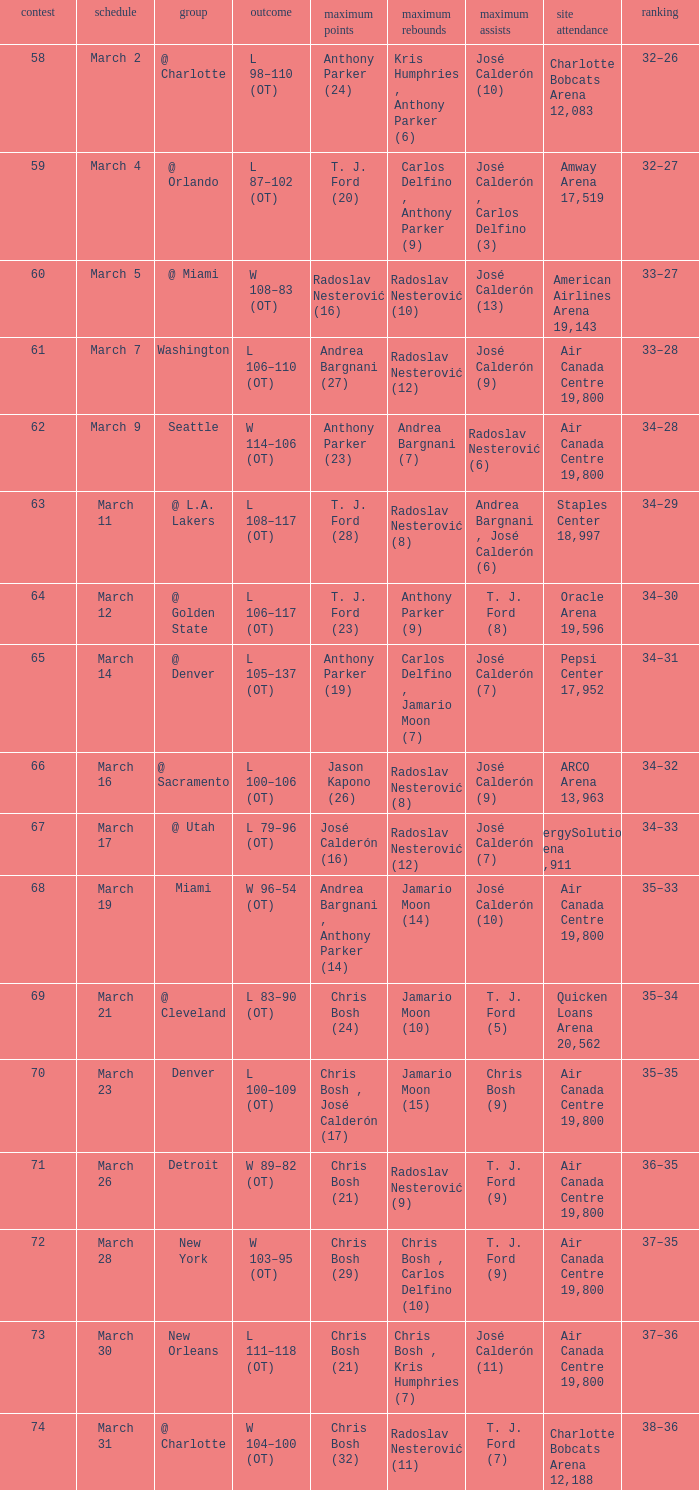Write the full table. {'header': ['contest', 'schedule', 'group', 'outcome', 'maximum points', 'maximum rebounds', 'maximum assists', 'site attendance', 'ranking'], 'rows': [['58', 'March 2', '@ Charlotte', 'L 98–110 (OT)', 'Anthony Parker (24)', 'Kris Humphries , Anthony Parker (6)', 'José Calderón (10)', 'Charlotte Bobcats Arena 12,083', '32–26'], ['59', 'March 4', '@ Orlando', 'L 87–102 (OT)', 'T. J. Ford (20)', 'Carlos Delfino , Anthony Parker (9)', 'José Calderón , Carlos Delfino (3)', 'Amway Arena 17,519', '32–27'], ['60', 'March 5', '@ Miami', 'W 108–83 (OT)', 'Radoslav Nesterović (16)', 'Radoslav Nesterović (10)', 'José Calderón (13)', 'American Airlines Arena 19,143', '33–27'], ['61', 'March 7', 'Washington', 'L 106–110 (OT)', 'Andrea Bargnani (27)', 'Radoslav Nesterović (12)', 'José Calderón (9)', 'Air Canada Centre 19,800', '33–28'], ['62', 'March 9', 'Seattle', 'W 114–106 (OT)', 'Anthony Parker (23)', 'Andrea Bargnani (7)', 'Radoslav Nesterović (6)', 'Air Canada Centre 19,800', '34–28'], ['63', 'March 11', '@ L.A. Lakers', 'L 108–117 (OT)', 'T. J. Ford (28)', 'Radoslav Nesterović (8)', 'Andrea Bargnani , José Calderón (6)', 'Staples Center 18,997', '34–29'], ['64', 'March 12', '@ Golden State', 'L 106–117 (OT)', 'T. J. Ford (23)', 'Anthony Parker (9)', 'T. J. Ford (8)', 'Oracle Arena 19,596', '34–30'], ['65', 'March 14', '@ Denver', 'L 105–137 (OT)', 'Anthony Parker (19)', 'Carlos Delfino , Jamario Moon (7)', 'José Calderón (7)', 'Pepsi Center 17,952', '34–31'], ['66', 'March 16', '@ Sacramento', 'L 100–106 (OT)', 'Jason Kapono (26)', 'Radoslav Nesterović (8)', 'José Calderón (9)', 'ARCO Arena 13,963', '34–32'], ['67', 'March 17', '@ Utah', 'L 79–96 (OT)', 'José Calderón (16)', 'Radoslav Nesterović (12)', 'José Calderón (7)', 'EnergySolutions Arena 19,911', '34–33'], ['68', 'March 19', 'Miami', 'W 96–54 (OT)', 'Andrea Bargnani , Anthony Parker (14)', 'Jamario Moon (14)', 'José Calderón (10)', 'Air Canada Centre 19,800', '35–33'], ['69', 'March 21', '@ Cleveland', 'L 83–90 (OT)', 'Chris Bosh (24)', 'Jamario Moon (10)', 'T. J. Ford (5)', 'Quicken Loans Arena 20,562', '35–34'], ['70', 'March 23', 'Denver', 'L 100–109 (OT)', 'Chris Bosh , José Calderón (17)', 'Jamario Moon (15)', 'Chris Bosh (9)', 'Air Canada Centre 19,800', '35–35'], ['71', 'March 26', 'Detroit', 'W 89–82 (OT)', 'Chris Bosh (21)', 'Radoslav Nesterović (9)', 'T. J. Ford (9)', 'Air Canada Centre 19,800', '36–35'], ['72', 'March 28', 'New York', 'W 103–95 (OT)', 'Chris Bosh (29)', 'Chris Bosh , Carlos Delfino (10)', 'T. J. Ford (9)', 'Air Canada Centre 19,800', '37–35'], ['73', 'March 30', 'New Orleans', 'L 111–118 (OT)', 'Chris Bosh (21)', 'Chris Bosh , Kris Humphries (7)', 'José Calderón (11)', 'Air Canada Centre 19,800', '37–36'], ['74', 'March 31', '@ Charlotte', 'W 104–100 (OT)', 'Chris Bosh (32)', 'Radoslav Nesterović (11)', 'T. J. Ford (7)', 'Charlotte Bobcats Arena 12,188', '38–36']]} What numbered game featured a High rebounds of radoslav nesterović (8), and a High assists of josé calderón (9)? 1.0. 